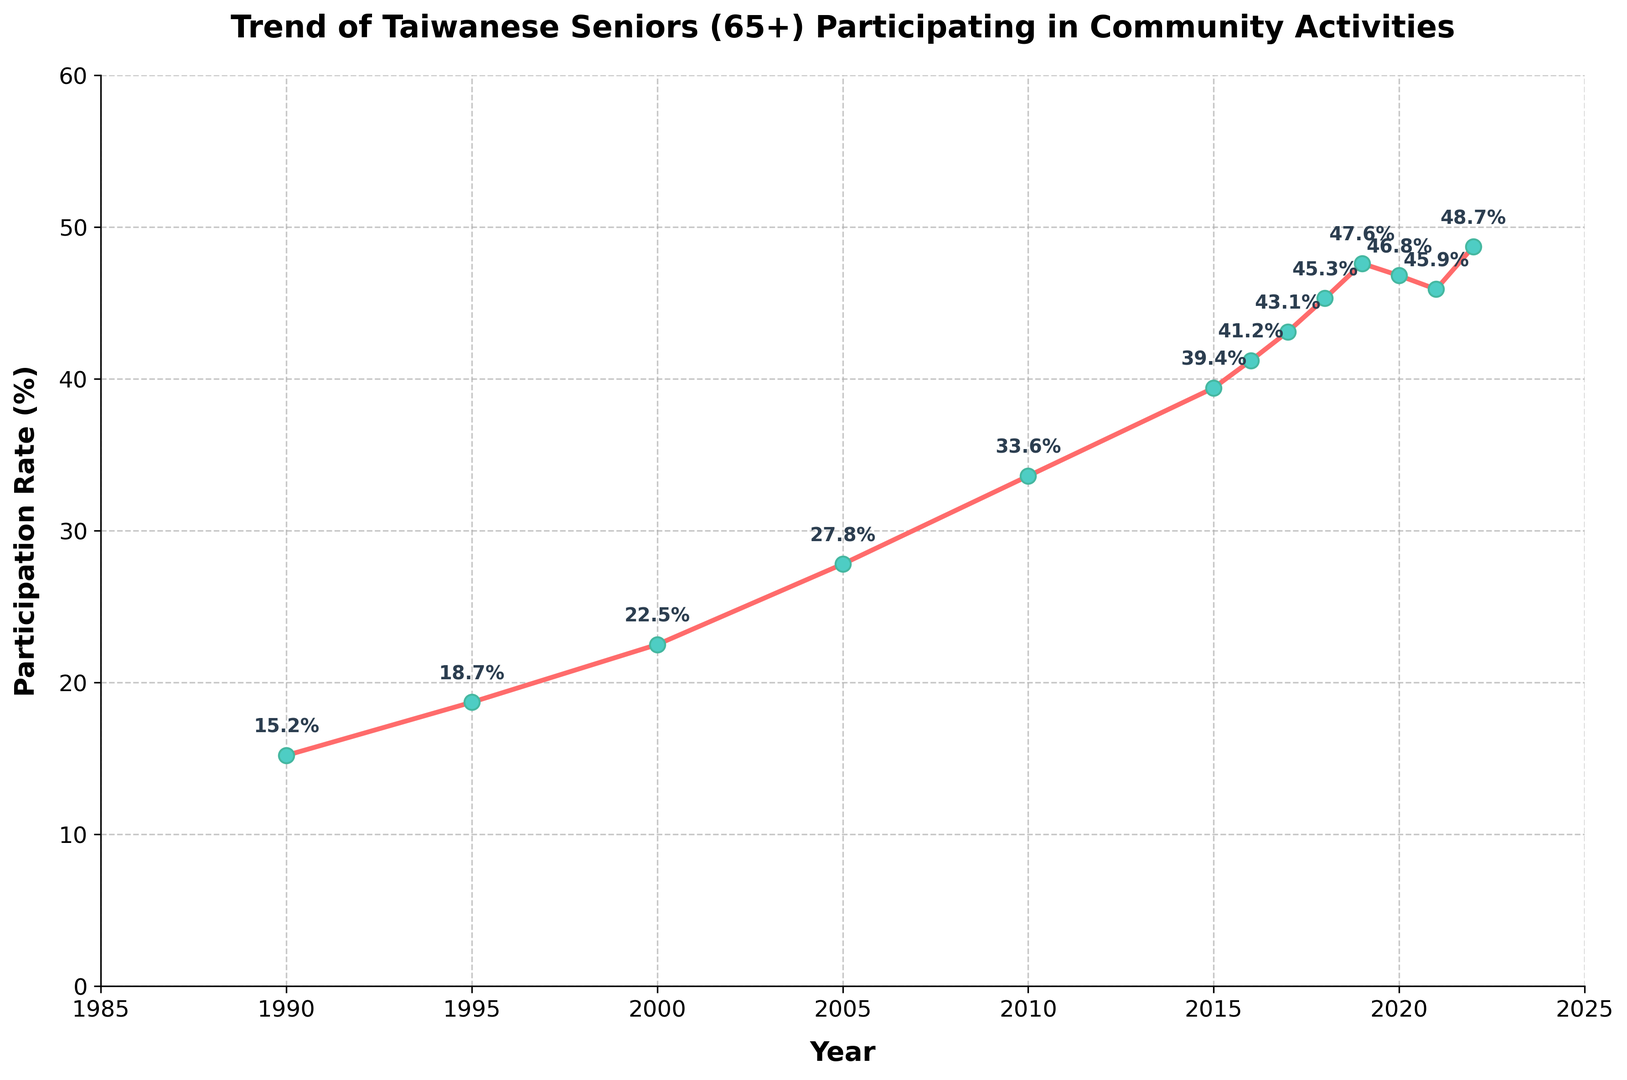What was the participation rate in the year 2010? By observing the figure, find the point that corresponds to the year 2010 on the x-axis. Then, check the corresponding value on the y-axis. The participation rate for 2010 is indicated as 33.6%.
Answer: 33.6% How much did the participation rate increase from 1990 to 2000? Locate the participation rates for the years 1990 (15.2%) and 2000 (22.5%). Calculate the difference by subtracting the 1990 value from the 2000 value: 22.5% - 15.2% = 7.3%.
Answer: 7.3% Which year had the highest participation rate, and what was that rate? From the figure, identify the year with the highest point. The highest participation rate is given by the point with the maximum y-value, which occurs in 2022 at 48.7%.
Answer: 2022, 48.7% How much did the participation rate change from 2019 to 2020? Look at the participation rates for 2019 (47.6%) and 2020 (46.8%). Calculate the change by subtracting the 2020 value from the 2019 value: 46.8% - 47.6% = -0.8%. The participation rate decreased by 0.8%.
Answer: -0.8% What is the average participation rate from 2015 to 2020? Identify the participation rates for the years 2015 (39.4%), 2016 (41.2%), 2017 (43.1%), 2018 (45.3%), 2019 (47.6%), and 2020 (46.8%). Calculate the average as follows: (39.4 + 41.2 + 43.1 + 45.3 + 47.6 + 46.8) / 6 = 43.9%.
Answer: 43.9% In which period was the increase in participation rate the highest? Calculate the differences in participation rates between consecutive five-year intervals: 
- 1990 to 1995: 18.7 - 15.2 = 3.5
- 1995 to 2000: 22.5 - 18.7 = 3.8
- 2000 to 2005: 27.8 - 22.5 = 5.3
- 2005 to 2010: 33.6 - 27.8 = 5.8
- 2010 to 2015: 39.4 - 33.6 = 5.8
The highest increase was in two periods: 2005 to 2010 and 2010 to 2015, both with an increase of 5.8%.
Answer: 2005 to 2010, 2010 to 2015 What is the trend in the participation rate from 2000 to 2022? By examining the overall direction of the line from 2000 to 2022, we see that the participation rate consistently increased over the period, despite minor fluctuations in the late 2010s.
Answer: Increasing How did the participation rate change between 2020 and 2021, and what could be a possible reason for this change? Identify the rates for 2020 (46.8%) and 2021 (45.9%). The rate decreased by 0.9% (46.8% - 45.9%). A possible reason for the decline could be the impact of the COVID-19 pandemic, leading to reduced community activities.
Answer: -0.9% What is the median participation rate over the entire period? Arrange the participation rates in ascending order: 15.2, 18.7, 22.5, 27.8, 33.6, 39.4, 41.2, 43.1, 45.3, 45.9, 46.8, 47.6, 48.7. Since there are 13 data points, the median rate is the 7th value: 41.2%.
Answer: 41.2% 